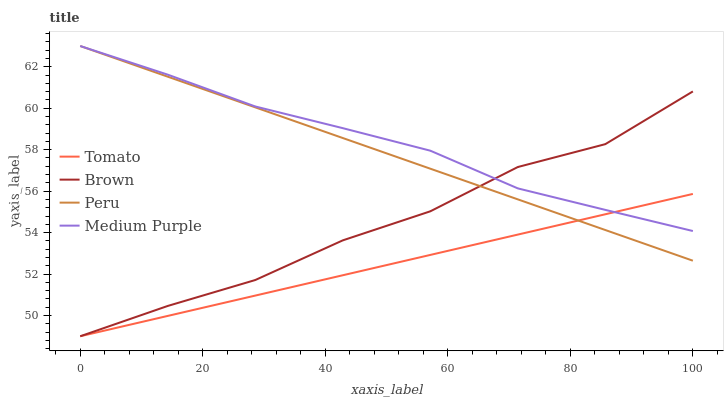Does Tomato have the minimum area under the curve?
Answer yes or no. Yes. Does Medium Purple have the maximum area under the curve?
Answer yes or no. Yes. Does Brown have the minimum area under the curve?
Answer yes or no. No. Does Brown have the maximum area under the curve?
Answer yes or no. No. Is Tomato the smoothest?
Answer yes or no. Yes. Is Brown the roughest?
Answer yes or no. Yes. Is Medium Purple the smoothest?
Answer yes or no. No. Is Medium Purple the roughest?
Answer yes or no. No. Does Tomato have the lowest value?
Answer yes or no. Yes. Does Medium Purple have the lowest value?
Answer yes or no. No. Does Peru have the highest value?
Answer yes or no. Yes. Does Brown have the highest value?
Answer yes or no. No. Does Medium Purple intersect Peru?
Answer yes or no. Yes. Is Medium Purple less than Peru?
Answer yes or no. No. Is Medium Purple greater than Peru?
Answer yes or no. No. 